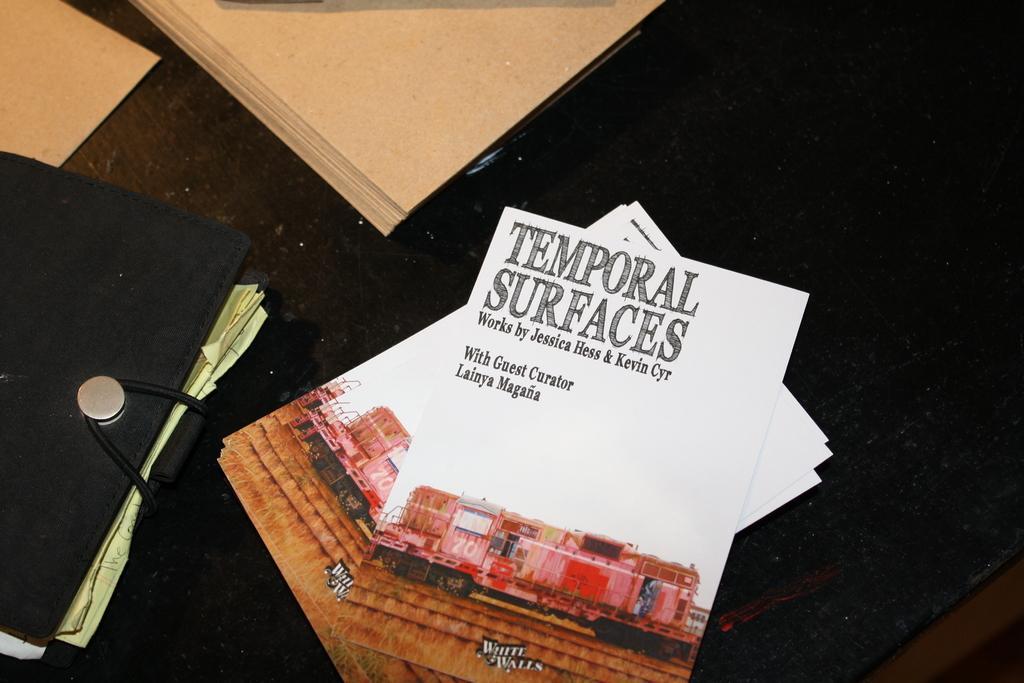Describe this image in one or two sentences. In this image, we can see some white color pamphlets and there is a file. 